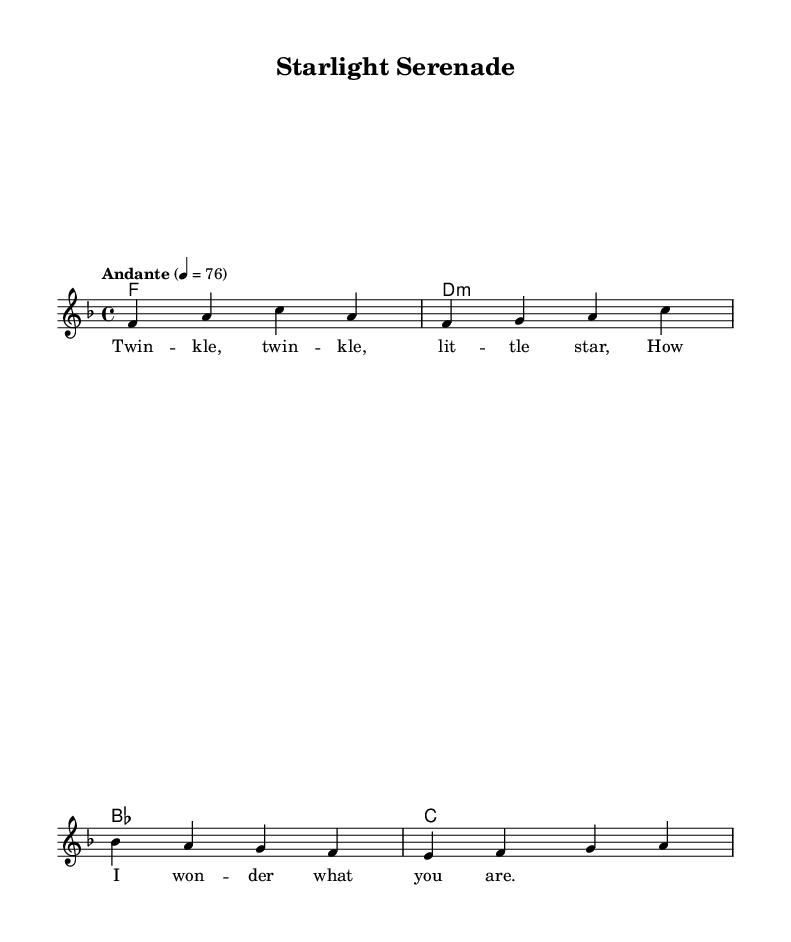What is the key signature of this music? The key signature is indicated at the beginning of the staff with one flat symbol, which represents F major or D minor.
Answer: F major What is the time signature of this music? The time signature appears next to the key signature and is shown as a fraction, with a 4 on top and a 4 on the bottom, indicating four beats per measure.
Answer: 4/4 What is the tempo marking of this piece? The tempo marking is written above the staff and reads "Andante" with a metronome mark of 76, suggesting a moderately slow pace.
Answer: Andante 4 = 76 How many measures are in the melody? By counting the distinct groupings of notes in the melody line, we can see that there are four distinct measures of music presented.
Answer: 4 What is the first note of the melody? The first note of the melody is the note that appears at the beginning of the melody line, which is F.
Answer: F What chords accompany the melody? The chords are presented in a separate section and follow the chord progression that aligns with the melody; they include F, D minor, B flat, and C.
Answer: F, D minor, B flat, C What type of music genre does this piece belong to? The piece is notated as a lullaby and is classified under the Soul genre, characterized by its emotional delivery and soothing quality.
Answer: Soul 